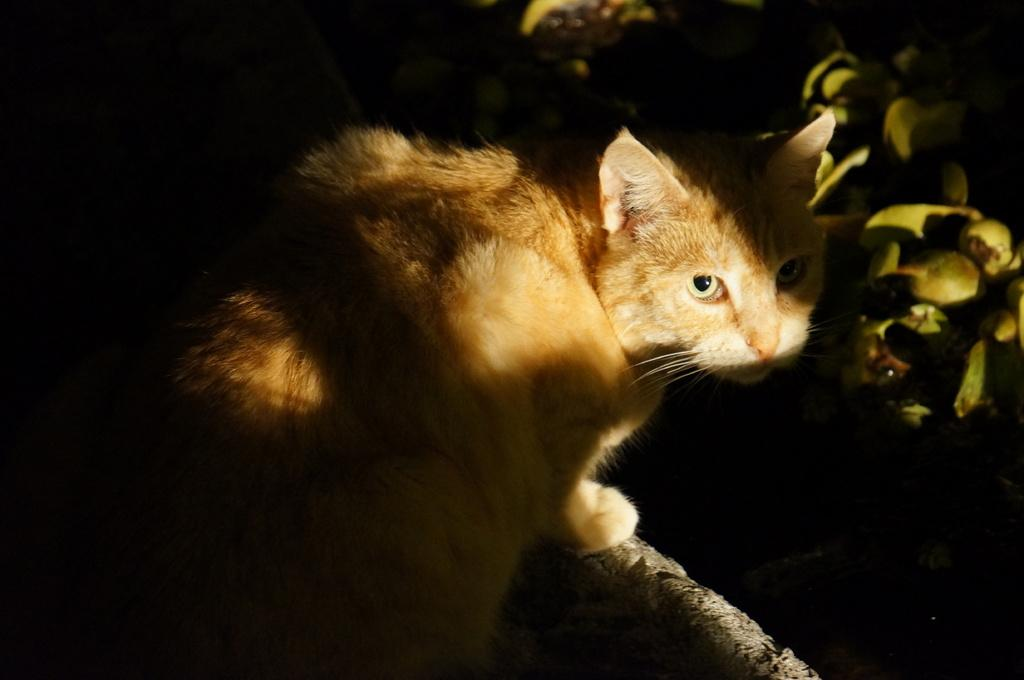What type of animal is in the image? There is a cat in the image. What is the cat doing or where is it located? The cat is on an object. What can be seen on the right side of the image? There are objects that resemble fruits on the right side of the image. How would you describe the overall lighting or color scheme of the image? The background of the image is dark. Can you see the cat watching the sea in the image? There is no sea present in the image, and the cat's activity is not mentioned, so it cannot be determined if the cat is watching the sea. 